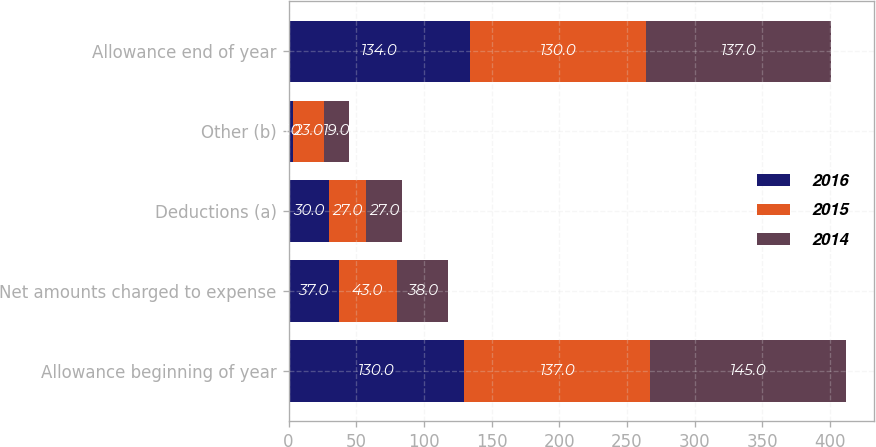Convert chart to OTSL. <chart><loc_0><loc_0><loc_500><loc_500><stacked_bar_chart><ecel><fcel>Allowance beginning of year<fcel>Net amounts charged to expense<fcel>Deductions (a)<fcel>Other (b)<fcel>Allowance end of year<nl><fcel>2016<fcel>130<fcel>37<fcel>30<fcel>3<fcel>134<nl><fcel>2015<fcel>137<fcel>43<fcel>27<fcel>23<fcel>130<nl><fcel>2014<fcel>145<fcel>38<fcel>27<fcel>19<fcel>137<nl></chart> 